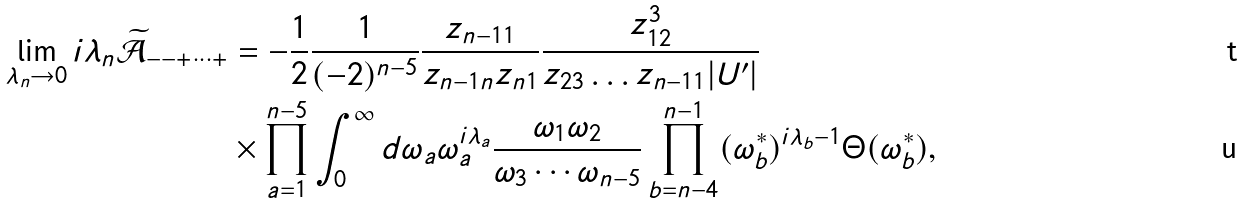<formula> <loc_0><loc_0><loc_500><loc_500>\lim _ { \lambda _ { n } \rightarrow 0 } i \lambda _ { n } \widetilde { \mathcal { A } } _ { - - + \dots + } & = - \frac { 1 } { 2 } \frac { 1 } { ( - 2 ) ^ { n - 5 } } \frac { z _ { n - 1 1 } } { z _ { n - 1 n } z _ { n 1 } } \frac { z _ { 1 2 } ^ { 3 } } { z _ { 2 3 } \dots z _ { n - 1 1 } | U ^ { \prime } | } \\ & \times \prod _ { a = 1 } ^ { n - 5 } \int _ { 0 } ^ { \infty } d \omega _ { a } \omega _ { a } ^ { i \lambda _ { a } } \frac { \omega _ { 1 } \omega _ { 2 } } { \omega _ { 3 } \cdots \omega _ { n - 5 } } \prod _ { b = n - 4 } ^ { n - 1 } ( \omega ^ { * } _ { b } ) ^ { i \lambda _ { b } - 1 } \Theta ( \omega _ { b } ^ { * } ) ,</formula> 